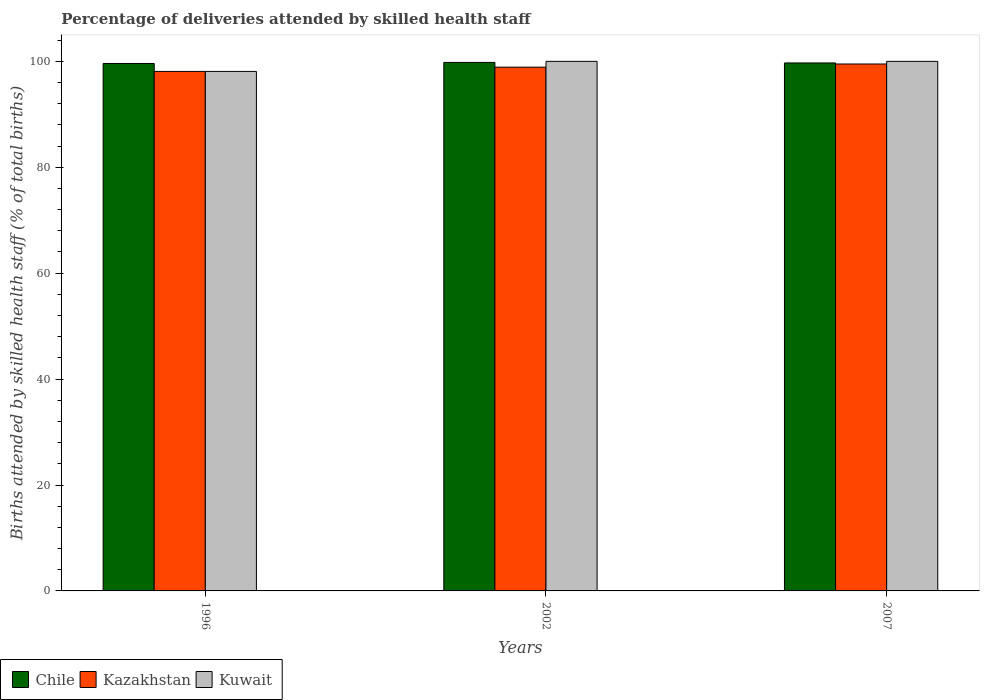Are the number of bars on each tick of the X-axis equal?
Keep it short and to the point. Yes. In how many cases, is the number of bars for a given year not equal to the number of legend labels?
Your response must be concise. 0. What is the percentage of births attended by skilled health staff in Kazakhstan in 2002?
Your answer should be compact. 98.9. Across all years, what is the maximum percentage of births attended by skilled health staff in Kazakhstan?
Offer a very short reply. 99.5. Across all years, what is the minimum percentage of births attended by skilled health staff in Chile?
Keep it short and to the point. 99.6. In which year was the percentage of births attended by skilled health staff in Kazakhstan maximum?
Ensure brevity in your answer.  2007. In which year was the percentage of births attended by skilled health staff in Chile minimum?
Your answer should be compact. 1996. What is the total percentage of births attended by skilled health staff in Kuwait in the graph?
Keep it short and to the point. 298.1. What is the difference between the percentage of births attended by skilled health staff in Chile in 1996 and that in 2002?
Make the answer very short. -0.2. What is the difference between the percentage of births attended by skilled health staff in Kazakhstan in 2002 and the percentage of births attended by skilled health staff in Chile in 1996?
Make the answer very short. -0.7. What is the average percentage of births attended by skilled health staff in Kazakhstan per year?
Ensure brevity in your answer.  98.83. In the year 2007, what is the difference between the percentage of births attended by skilled health staff in Kuwait and percentage of births attended by skilled health staff in Chile?
Your response must be concise. 0.3. What is the ratio of the percentage of births attended by skilled health staff in Kuwait in 1996 to that in 2007?
Provide a short and direct response. 0.98. Is the percentage of births attended by skilled health staff in Kazakhstan in 2002 less than that in 2007?
Make the answer very short. Yes. Is the difference between the percentage of births attended by skilled health staff in Kuwait in 2002 and 2007 greater than the difference between the percentage of births attended by skilled health staff in Chile in 2002 and 2007?
Make the answer very short. No. What is the difference between the highest and the second highest percentage of births attended by skilled health staff in Kazakhstan?
Your answer should be compact. 0.6. What is the difference between the highest and the lowest percentage of births attended by skilled health staff in Kuwait?
Offer a terse response. 1.9. What does the 3rd bar from the left in 2007 represents?
Your answer should be very brief. Kuwait. What does the 2nd bar from the right in 2002 represents?
Your answer should be compact. Kazakhstan. How many bars are there?
Provide a succinct answer. 9. How many years are there in the graph?
Your response must be concise. 3. Does the graph contain grids?
Make the answer very short. No. Where does the legend appear in the graph?
Give a very brief answer. Bottom left. How many legend labels are there?
Your answer should be very brief. 3. What is the title of the graph?
Give a very brief answer. Percentage of deliveries attended by skilled health staff. What is the label or title of the X-axis?
Your answer should be very brief. Years. What is the label or title of the Y-axis?
Give a very brief answer. Births attended by skilled health staff (% of total births). What is the Births attended by skilled health staff (% of total births) in Chile in 1996?
Your answer should be very brief. 99.6. What is the Births attended by skilled health staff (% of total births) of Kazakhstan in 1996?
Your response must be concise. 98.1. What is the Births attended by skilled health staff (% of total births) of Kuwait in 1996?
Offer a very short reply. 98.1. What is the Births attended by skilled health staff (% of total births) in Chile in 2002?
Your response must be concise. 99.8. What is the Births attended by skilled health staff (% of total births) of Kazakhstan in 2002?
Provide a short and direct response. 98.9. What is the Births attended by skilled health staff (% of total births) in Chile in 2007?
Make the answer very short. 99.7. What is the Births attended by skilled health staff (% of total births) of Kazakhstan in 2007?
Your answer should be very brief. 99.5. What is the Births attended by skilled health staff (% of total births) in Kuwait in 2007?
Ensure brevity in your answer.  100. Across all years, what is the maximum Births attended by skilled health staff (% of total births) in Chile?
Give a very brief answer. 99.8. Across all years, what is the maximum Births attended by skilled health staff (% of total births) in Kazakhstan?
Provide a short and direct response. 99.5. Across all years, what is the maximum Births attended by skilled health staff (% of total births) of Kuwait?
Your response must be concise. 100. Across all years, what is the minimum Births attended by skilled health staff (% of total births) of Chile?
Make the answer very short. 99.6. Across all years, what is the minimum Births attended by skilled health staff (% of total births) in Kazakhstan?
Your answer should be compact. 98.1. Across all years, what is the minimum Births attended by skilled health staff (% of total births) in Kuwait?
Offer a very short reply. 98.1. What is the total Births attended by skilled health staff (% of total births) of Chile in the graph?
Ensure brevity in your answer.  299.1. What is the total Births attended by skilled health staff (% of total births) of Kazakhstan in the graph?
Make the answer very short. 296.5. What is the total Births attended by skilled health staff (% of total births) of Kuwait in the graph?
Offer a terse response. 298.1. What is the difference between the Births attended by skilled health staff (% of total births) in Chile in 1996 and that in 2002?
Make the answer very short. -0.2. What is the difference between the Births attended by skilled health staff (% of total births) in Kazakhstan in 1996 and that in 2002?
Provide a succinct answer. -0.8. What is the difference between the Births attended by skilled health staff (% of total births) of Kuwait in 1996 and that in 2002?
Your answer should be very brief. -1.9. What is the difference between the Births attended by skilled health staff (% of total births) of Chile in 1996 and that in 2007?
Give a very brief answer. -0.1. What is the difference between the Births attended by skilled health staff (% of total births) in Kuwait in 1996 and that in 2007?
Provide a succinct answer. -1.9. What is the difference between the Births attended by skilled health staff (% of total births) in Chile in 2002 and that in 2007?
Give a very brief answer. 0.1. What is the difference between the Births attended by skilled health staff (% of total births) in Chile in 1996 and the Births attended by skilled health staff (% of total births) in Kuwait in 2002?
Your response must be concise. -0.4. What is the difference between the Births attended by skilled health staff (% of total births) of Kazakhstan in 1996 and the Births attended by skilled health staff (% of total births) of Kuwait in 2002?
Keep it short and to the point. -1.9. What is the difference between the Births attended by skilled health staff (% of total births) in Kazakhstan in 2002 and the Births attended by skilled health staff (% of total births) in Kuwait in 2007?
Offer a very short reply. -1.1. What is the average Births attended by skilled health staff (% of total births) of Chile per year?
Your answer should be compact. 99.7. What is the average Births attended by skilled health staff (% of total births) in Kazakhstan per year?
Your response must be concise. 98.83. What is the average Births attended by skilled health staff (% of total births) of Kuwait per year?
Offer a terse response. 99.37. In the year 1996, what is the difference between the Births attended by skilled health staff (% of total births) in Chile and Births attended by skilled health staff (% of total births) in Kuwait?
Give a very brief answer. 1.5. In the year 1996, what is the difference between the Births attended by skilled health staff (% of total births) in Kazakhstan and Births attended by skilled health staff (% of total births) in Kuwait?
Make the answer very short. 0. In the year 2002, what is the difference between the Births attended by skilled health staff (% of total births) of Chile and Births attended by skilled health staff (% of total births) of Kazakhstan?
Offer a very short reply. 0.9. In the year 2002, what is the difference between the Births attended by skilled health staff (% of total births) of Chile and Births attended by skilled health staff (% of total births) of Kuwait?
Keep it short and to the point. -0.2. In the year 2007, what is the difference between the Births attended by skilled health staff (% of total births) of Chile and Births attended by skilled health staff (% of total births) of Kazakhstan?
Make the answer very short. 0.2. In the year 2007, what is the difference between the Births attended by skilled health staff (% of total births) in Kazakhstan and Births attended by skilled health staff (% of total births) in Kuwait?
Your response must be concise. -0.5. What is the ratio of the Births attended by skilled health staff (% of total births) of Kazakhstan in 1996 to that in 2007?
Offer a terse response. 0.99. What is the ratio of the Births attended by skilled health staff (% of total births) of Kuwait in 1996 to that in 2007?
Provide a succinct answer. 0.98. What is the ratio of the Births attended by skilled health staff (% of total births) of Chile in 2002 to that in 2007?
Offer a terse response. 1. What is the difference between the highest and the lowest Births attended by skilled health staff (% of total births) in Chile?
Your answer should be compact. 0.2. What is the difference between the highest and the lowest Births attended by skilled health staff (% of total births) in Kuwait?
Make the answer very short. 1.9. 